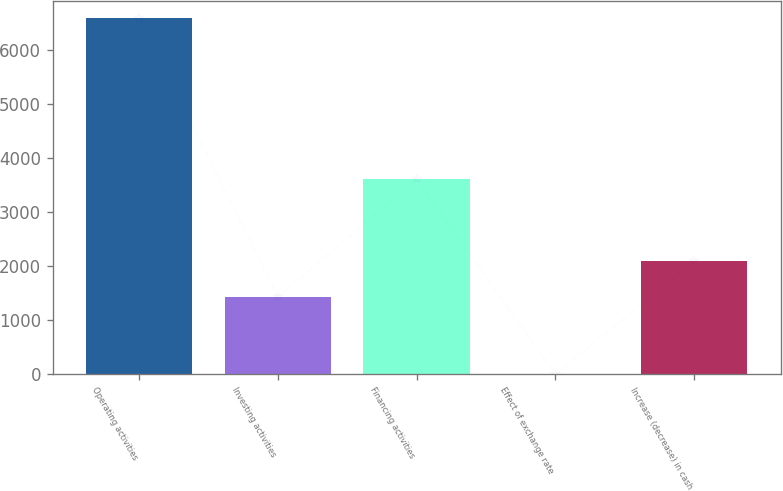<chart> <loc_0><loc_0><loc_500><loc_500><bar_chart><fcel>Operating activities<fcel>Investing activities<fcel>Financing activities<fcel>Effect of exchange rate<fcel>Increase (decrease) in cash<nl><fcel>6584<fcel>1435<fcel>3603<fcel>1<fcel>2093.3<nl></chart> 